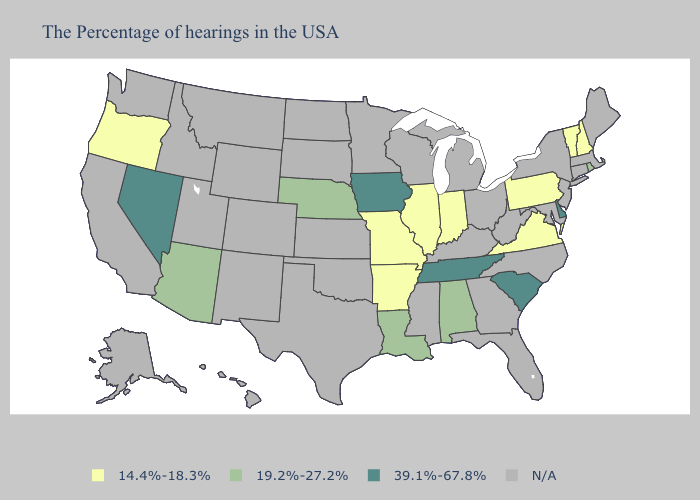What is the value of Alabama?
Answer briefly. 19.2%-27.2%. Which states hav the highest value in the South?
Concise answer only. Delaware, South Carolina, Tennessee. Does the map have missing data?
Concise answer only. Yes. What is the value of Massachusetts?
Concise answer only. N/A. What is the value of Utah?
Concise answer only. N/A. What is the lowest value in the USA?
Be succinct. 14.4%-18.3%. Does the map have missing data?
Quick response, please. Yes. Name the states that have a value in the range N/A?
Write a very short answer. Maine, Massachusetts, Connecticut, New York, New Jersey, Maryland, North Carolina, West Virginia, Ohio, Florida, Georgia, Michigan, Kentucky, Wisconsin, Mississippi, Minnesota, Kansas, Oklahoma, Texas, South Dakota, North Dakota, Wyoming, Colorado, New Mexico, Utah, Montana, Idaho, California, Washington, Alaska, Hawaii. What is the lowest value in states that border New Hampshire?
Write a very short answer. 14.4%-18.3%. What is the value of New York?
Concise answer only. N/A. What is the value of Florida?
Answer briefly. N/A. Does the map have missing data?
Keep it brief. Yes. Among the states that border Wisconsin , which have the highest value?
Concise answer only. Iowa. What is the value of Pennsylvania?
Write a very short answer. 14.4%-18.3%. 